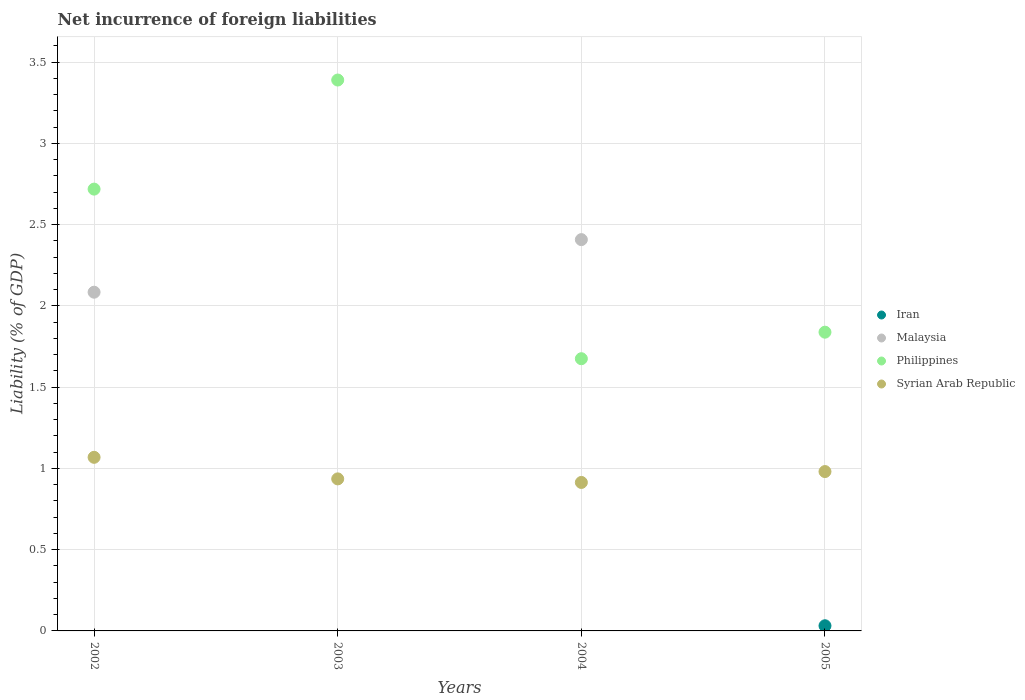How many different coloured dotlines are there?
Offer a terse response. 4. What is the net incurrence of foreign liabilities in Philippines in 2004?
Your answer should be very brief. 1.67. Across all years, what is the maximum net incurrence of foreign liabilities in Malaysia?
Provide a succinct answer. 2.41. In which year was the net incurrence of foreign liabilities in Syrian Arab Republic maximum?
Give a very brief answer. 2002. What is the total net incurrence of foreign liabilities in Philippines in the graph?
Provide a short and direct response. 9.62. What is the difference between the net incurrence of foreign liabilities in Philippines in 2003 and that in 2005?
Offer a terse response. 1.55. What is the difference between the net incurrence of foreign liabilities in Philippines in 2003 and the net incurrence of foreign liabilities in Iran in 2005?
Your answer should be very brief. 3.36. What is the average net incurrence of foreign liabilities in Syrian Arab Republic per year?
Your answer should be compact. 0.97. In the year 2003, what is the difference between the net incurrence of foreign liabilities in Syrian Arab Republic and net incurrence of foreign liabilities in Philippines?
Give a very brief answer. -2.45. In how many years, is the net incurrence of foreign liabilities in Malaysia greater than 2.1 %?
Make the answer very short. 1. What is the ratio of the net incurrence of foreign liabilities in Philippines in 2004 to that in 2005?
Your answer should be very brief. 0.91. Is the difference between the net incurrence of foreign liabilities in Syrian Arab Republic in 2002 and 2005 greater than the difference between the net incurrence of foreign liabilities in Philippines in 2002 and 2005?
Your answer should be very brief. No. What is the difference between the highest and the second highest net incurrence of foreign liabilities in Syrian Arab Republic?
Offer a very short reply. 0.09. What is the difference between the highest and the lowest net incurrence of foreign liabilities in Malaysia?
Provide a short and direct response. 2.41. In how many years, is the net incurrence of foreign liabilities in Iran greater than the average net incurrence of foreign liabilities in Iran taken over all years?
Make the answer very short. 1. Is it the case that in every year, the sum of the net incurrence of foreign liabilities in Malaysia and net incurrence of foreign liabilities in Syrian Arab Republic  is greater than the net incurrence of foreign liabilities in Philippines?
Keep it short and to the point. No. Is the net incurrence of foreign liabilities in Syrian Arab Republic strictly greater than the net incurrence of foreign liabilities in Iran over the years?
Offer a very short reply. Yes. Is the net incurrence of foreign liabilities in Iran strictly less than the net incurrence of foreign liabilities in Malaysia over the years?
Offer a terse response. No. How many dotlines are there?
Provide a succinct answer. 4. How many years are there in the graph?
Offer a very short reply. 4. What is the difference between two consecutive major ticks on the Y-axis?
Provide a succinct answer. 0.5. Are the values on the major ticks of Y-axis written in scientific E-notation?
Make the answer very short. No. Does the graph contain grids?
Your answer should be compact. Yes. How many legend labels are there?
Your response must be concise. 4. How are the legend labels stacked?
Ensure brevity in your answer.  Vertical. What is the title of the graph?
Offer a very short reply. Net incurrence of foreign liabilities. What is the label or title of the Y-axis?
Provide a succinct answer. Liability (% of GDP). What is the Liability (% of GDP) in Malaysia in 2002?
Your answer should be compact. 2.08. What is the Liability (% of GDP) of Philippines in 2002?
Provide a succinct answer. 2.72. What is the Liability (% of GDP) of Syrian Arab Republic in 2002?
Ensure brevity in your answer.  1.07. What is the Liability (% of GDP) in Iran in 2003?
Give a very brief answer. 0. What is the Liability (% of GDP) in Philippines in 2003?
Provide a succinct answer. 3.39. What is the Liability (% of GDP) in Syrian Arab Republic in 2003?
Provide a short and direct response. 0.94. What is the Liability (% of GDP) in Iran in 2004?
Make the answer very short. 0. What is the Liability (% of GDP) of Malaysia in 2004?
Provide a short and direct response. 2.41. What is the Liability (% of GDP) of Philippines in 2004?
Your answer should be compact. 1.67. What is the Liability (% of GDP) of Syrian Arab Republic in 2004?
Your answer should be very brief. 0.91. What is the Liability (% of GDP) of Iran in 2005?
Make the answer very short. 0.03. What is the Liability (% of GDP) of Malaysia in 2005?
Offer a very short reply. 0. What is the Liability (% of GDP) of Philippines in 2005?
Your response must be concise. 1.84. What is the Liability (% of GDP) of Syrian Arab Republic in 2005?
Offer a very short reply. 0.98. Across all years, what is the maximum Liability (% of GDP) of Iran?
Your response must be concise. 0.03. Across all years, what is the maximum Liability (% of GDP) of Malaysia?
Ensure brevity in your answer.  2.41. Across all years, what is the maximum Liability (% of GDP) of Philippines?
Offer a terse response. 3.39. Across all years, what is the maximum Liability (% of GDP) in Syrian Arab Republic?
Make the answer very short. 1.07. Across all years, what is the minimum Liability (% of GDP) of Malaysia?
Provide a succinct answer. 0. Across all years, what is the minimum Liability (% of GDP) in Philippines?
Provide a short and direct response. 1.67. Across all years, what is the minimum Liability (% of GDP) in Syrian Arab Republic?
Your answer should be very brief. 0.91. What is the total Liability (% of GDP) in Iran in the graph?
Offer a very short reply. 0.03. What is the total Liability (% of GDP) in Malaysia in the graph?
Your answer should be compact. 4.49. What is the total Liability (% of GDP) in Philippines in the graph?
Keep it short and to the point. 9.62. What is the total Liability (% of GDP) of Syrian Arab Republic in the graph?
Give a very brief answer. 3.9. What is the difference between the Liability (% of GDP) of Philippines in 2002 and that in 2003?
Your answer should be compact. -0.67. What is the difference between the Liability (% of GDP) in Syrian Arab Republic in 2002 and that in 2003?
Your response must be concise. 0.13. What is the difference between the Liability (% of GDP) in Malaysia in 2002 and that in 2004?
Offer a very short reply. -0.32. What is the difference between the Liability (% of GDP) of Philippines in 2002 and that in 2004?
Make the answer very short. 1.04. What is the difference between the Liability (% of GDP) in Syrian Arab Republic in 2002 and that in 2004?
Offer a terse response. 0.15. What is the difference between the Liability (% of GDP) of Philippines in 2002 and that in 2005?
Give a very brief answer. 0.88. What is the difference between the Liability (% of GDP) in Syrian Arab Republic in 2002 and that in 2005?
Give a very brief answer. 0.09. What is the difference between the Liability (% of GDP) in Philippines in 2003 and that in 2004?
Keep it short and to the point. 1.71. What is the difference between the Liability (% of GDP) of Syrian Arab Republic in 2003 and that in 2004?
Your response must be concise. 0.02. What is the difference between the Liability (% of GDP) of Philippines in 2003 and that in 2005?
Offer a very short reply. 1.55. What is the difference between the Liability (% of GDP) of Syrian Arab Republic in 2003 and that in 2005?
Offer a terse response. -0.05. What is the difference between the Liability (% of GDP) of Philippines in 2004 and that in 2005?
Your answer should be very brief. -0.16. What is the difference between the Liability (% of GDP) in Syrian Arab Republic in 2004 and that in 2005?
Provide a short and direct response. -0.07. What is the difference between the Liability (% of GDP) in Malaysia in 2002 and the Liability (% of GDP) in Philippines in 2003?
Your answer should be compact. -1.31. What is the difference between the Liability (% of GDP) in Malaysia in 2002 and the Liability (% of GDP) in Syrian Arab Republic in 2003?
Provide a succinct answer. 1.15. What is the difference between the Liability (% of GDP) of Philippines in 2002 and the Liability (% of GDP) of Syrian Arab Republic in 2003?
Give a very brief answer. 1.78. What is the difference between the Liability (% of GDP) in Malaysia in 2002 and the Liability (% of GDP) in Philippines in 2004?
Offer a terse response. 0.41. What is the difference between the Liability (% of GDP) of Malaysia in 2002 and the Liability (% of GDP) of Syrian Arab Republic in 2004?
Make the answer very short. 1.17. What is the difference between the Liability (% of GDP) in Philippines in 2002 and the Liability (% of GDP) in Syrian Arab Republic in 2004?
Provide a short and direct response. 1.8. What is the difference between the Liability (% of GDP) in Malaysia in 2002 and the Liability (% of GDP) in Philippines in 2005?
Keep it short and to the point. 0.25. What is the difference between the Liability (% of GDP) of Malaysia in 2002 and the Liability (% of GDP) of Syrian Arab Republic in 2005?
Offer a terse response. 1.1. What is the difference between the Liability (% of GDP) of Philippines in 2002 and the Liability (% of GDP) of Syrian Arab Republic in 2005?
Provide a short and direct response. 1.74. What is the difference between the Liability (% of GDP) in Philippines in 2003 and the Liability (% of GDP) in Syrian Arab Republic in 2004?
Your response must be concise. 2.48. What is the difference between the Liability (% of GDP) of Philippines in 2003 and the Liability (% of GDP) of Syrian Arab Republic in 2005?
Offer a very short reply. 2.41. What is the difference between the Liability (% of GDP) of Malaysia in 2004 and the Liability (% of GDP) of Philippines in 2005?
Your answer should be very brief. 0.57. What is the difference between the Liability (% of GDP) in Malaysia in 2004 and the Liability (% of GDP) in Syrian Arab Republic in 2005?
Give a very brief answer. 1.43. What is the difference between the Liability (% of GDP) in Philippines in 2004 and the Liability (% of GDP) in Syrian Arab Republic in 2005?
Provide a short and direct response. 0.69. What is the average Liability (% of GDP) in Iran per year?
Keep it short and to the point. 0.01. What is the average Liability (% of GDP) of Malaysia per year?
Provide a short and direct response. 1.12. What is the average Liability (% of GDP) of Philippines per year?
Your answer should be very brief. 2.4. What is the average Liability (% of GDP) of Syrian Arab Republic per year?
Provide a short and direct response. 0.97. In the year 2002, what is the difference between the Liability (% of GDP) of Malaysia and Liability (% of GDP) of Philippines?
Give a very brief answer. -0.63. In the year 2002, what is the difference between the Liability (% of GDP) in Malaysia and Liability (% of GDP) in Syrian Arab Republic?
Your answer should be compact. 1.02. In the year 2002, what is the difference between the Liability (% of GDP) of Philippines and Liability (% of GDP) of Syrian Arab Republic?
Make the answer very short. 1.65. In the year 2003, what is the difference between the Liability (% of GDP) of Philippines and Liability (% of GDP) of Syrian Arab Republic?
Keep it short and to the point. 2.45. In the year 2004, what is the difference between the Liability (% of GDP) in Malaysia and Liability (% of GDP) in Philippines?
Offer a very short reply. 0.73. In the year 2004, what is the difference between the Liability (% of GDP) in Malaysia and Liability (% of GDP) in Syrian Arab Republic?
Make the answer very short. 1.49. In the year 2004, what is the difference between the Liability (% of GDP) in Philippines and Liability (% of GDP) in Syrian Arab Republic?
Give a very brief answer. 0.76. In the year 2005, what is the difference between the Liability (% of GDP) of Iran and Liability (% of GDP) of Philippines?
Provide a short and direct response. -1.81. In the year 2005, what is the difference between the Liability (% of GDP) in Iran and Liability (% of GDP) in Syrian Arab Republic?
Provide a succinct answer. -0.95. In the year 2005, what is the difference between the Liability (% of GDP) of Philippines and Liability (% of GDP) of Syrian Arab Republic?
Ensure brevity in your answer.  0.86. What is the ratio of the Liability (% of GDP) of Philippines in 2002 to that in 2003?
Provide a short and direct response. 0.8. What is the ratio of the Liability (% of GDP) of Syrian Arab Republic in 2002 to that in 2003?
Provide a short and direct response. 1.14. What is the ratio of the Liability (% of GDP) in Malaysia in 2002 to that in 2004?
Provide a short and direct response. 0.87. What is the ratio of the Liability (% of GDP) of Philippines in 2002 to that in 2004?
Your answer should be compact. 1.62. What is the ratio of the Liability (% of GDP) in Syrian Arab Republic in 2002 to that in 2004?
Ensure brevity in your answer.  1.17. What is the ratio of the Liability (% of GDP) in Philippines in 2002 to that in 2005?
Your answer should be compact. 1.48. What is the ratio of the Liability (% of GDP) in Syrian Arab Republic in 2002 to that in 2005?
Your answer should be compact. 1.09. What is the ratio of the Liability (% of GDP) of Philippines in 2003 to that in 2004?
Ensure brevity in your answer.  2.02. What is the ratio of the Liability (% of GDP) in Philippines in 2003 to that in 2005?
Give a very brief answer. 1.84. What is the ratio of the Liability (% of GDP) in Syrian Arab Republic in 2003 to that in 2005?
Your answer should be very brief. 0.95. What is the ratio of the Liability (% of GDP) of Philippines in 2004 to that in 2005?
Offer a terse response. 0.91. What is the ratio of the Liability (% of GDP) of Syrian Arab Republic in 2004 to that in 2005?
Ensure brevity in your answer.  0.93. What is the difference between the highest and the second highest Liability (% of GDP) in Philippines?
Offer a terse response. 0.67. What is the difference between the highest and the second highest Liability (% of GDP) in Syrian Arab Republic?
Offer a very short reply. 0.09. What is the difference between the highest and the lowest Liability (% of GDP) in Iran?
Your response must be concise. 0.03. What is the difference between the highest and the lowest Liability (% of GDP) in Malaysia?
Your answer should be compact. 2.41. What is the difference between the highest and the lowest Liability (% of GDP) in Philippines?
Ensure brevity in your answer.  1.71. What is the difference between the highest and the lowest Liability (% of GDP) of Syrian Arab Republic?
Offer a very short reply. 0.15. 